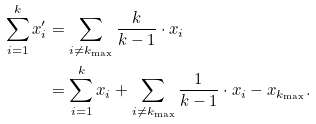Convert formula to latex. <formula><loc_0><loc_0><loc_500><loc_500>\sum _ { i = 1 } ^ { k } x _ { i } ^ { \prime } & = \sum _ { i \neq k _ { \max } } \frac { k } { k - 1 } \cdot x _ { i } \\ & = \sum _ { i = 1 } ^ { k } x _ { i } + \sum _ { i \neq k _ { \max } } \frac { 1 } { k - 1 } \cdot x _ { i } - x _ { k _ { \max } } .</formula> 